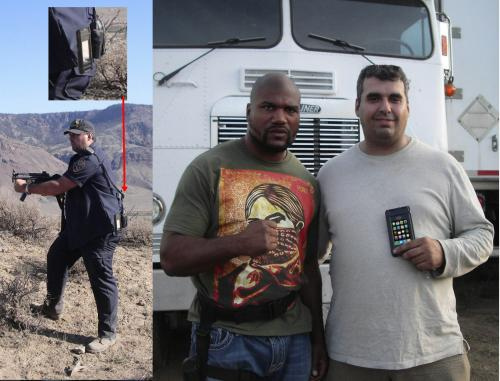Identify the text contained in this image. INER 